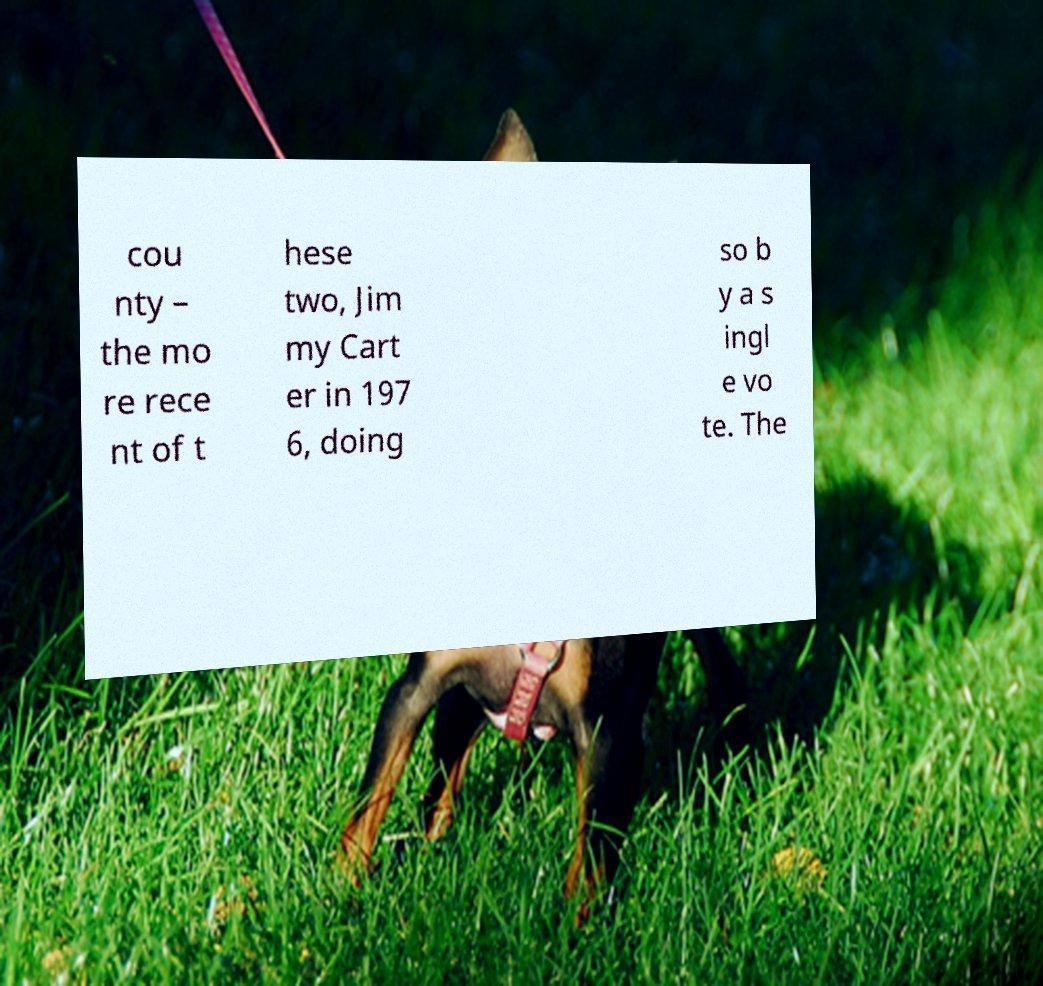Could you assist in decoding the text presented in this image and type it out clearly? cou nty – the mo re rece nt of t hese two, Jim my Cart er in 197 6, doing so b y a s ingl e vo te. The 